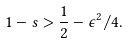<formula> <loc_0><loc_0><loc_500><loc_500>1 - s > \frac { 1 } { 2 } - \epsilon ^ { 2 } / 4 .</formula> 